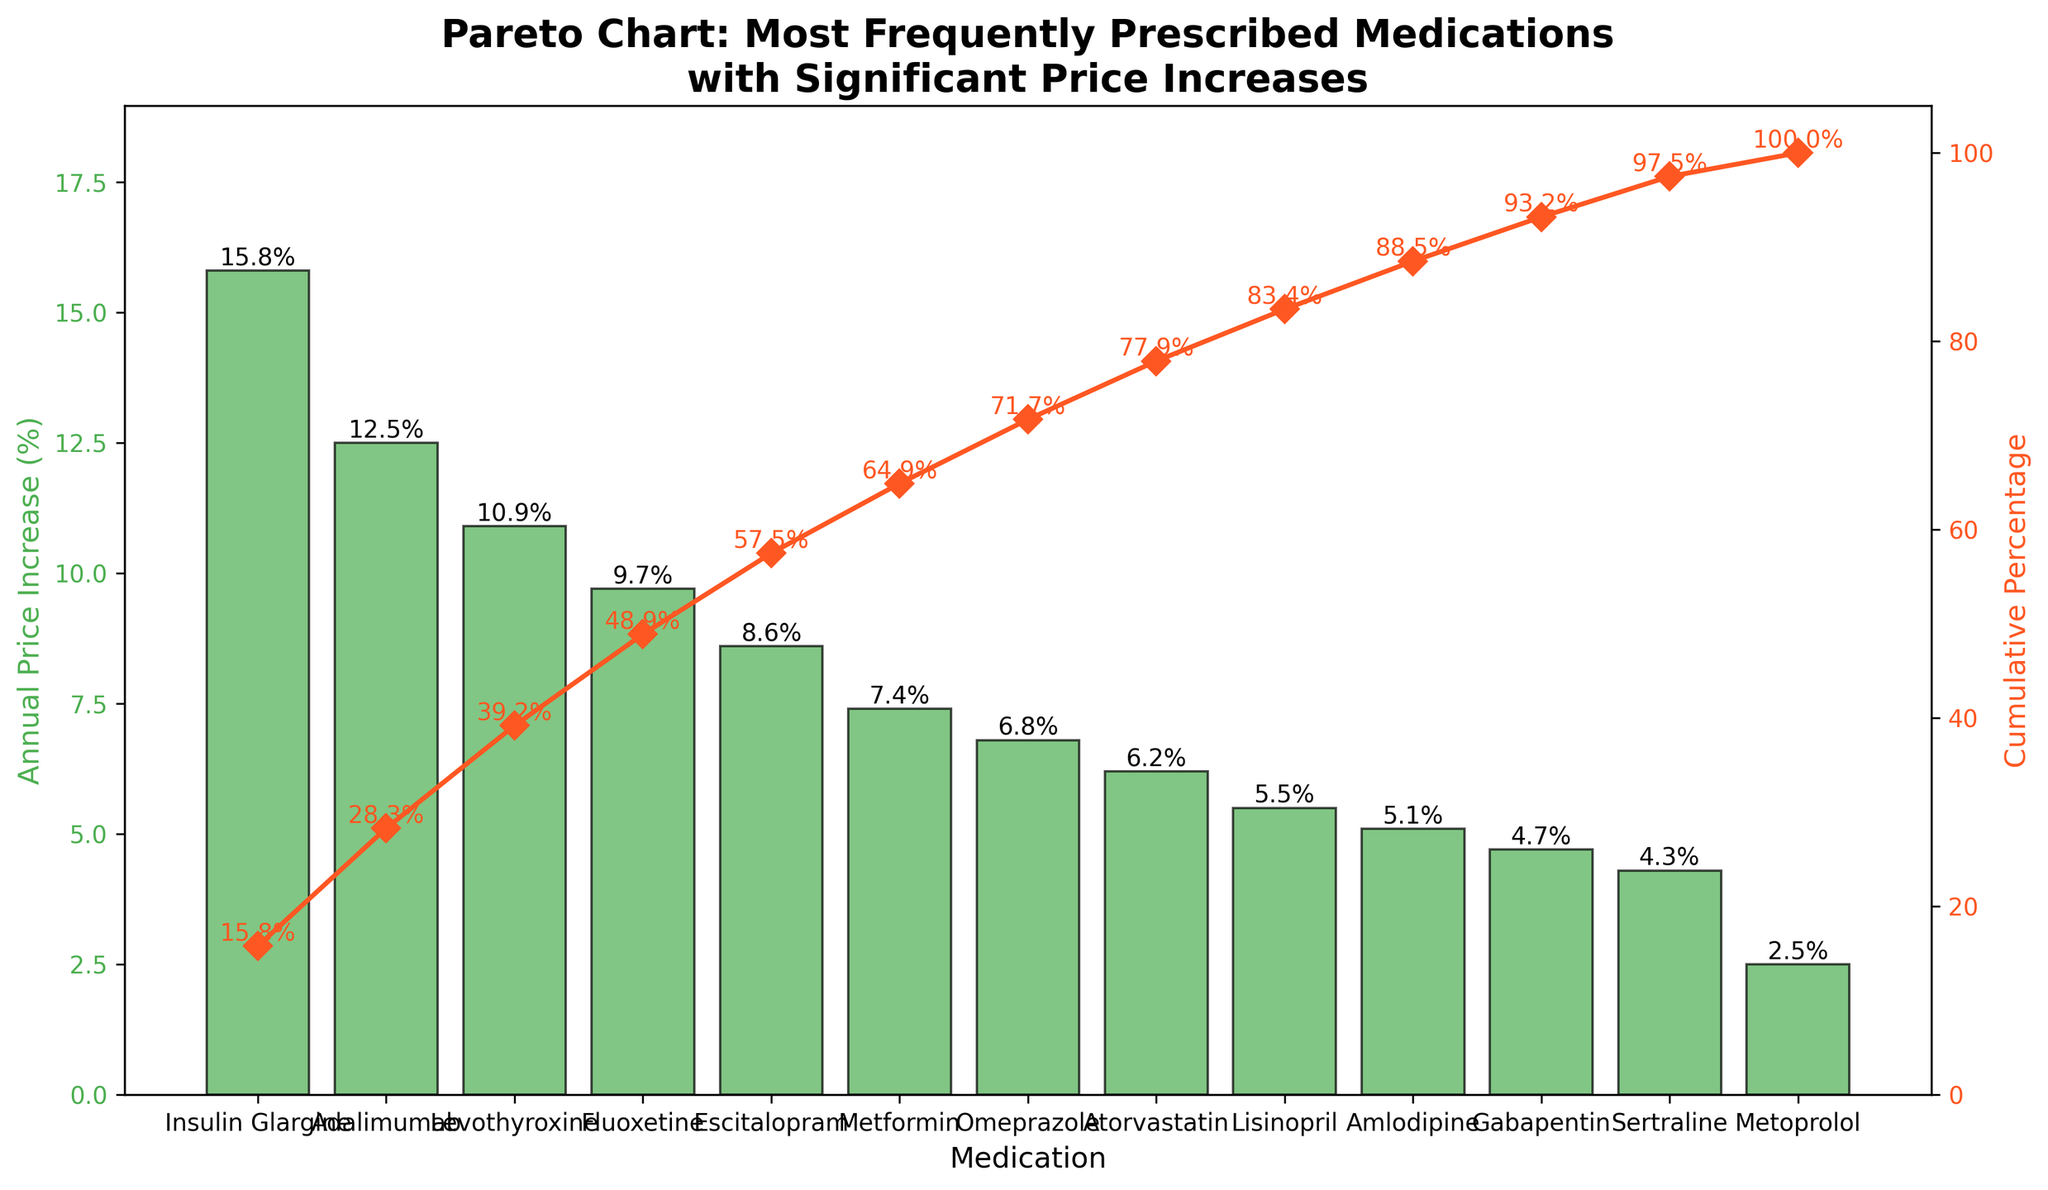What is the medication with the highest annual price increase? The bar chart shows the price increase percentages for each medication. By observing the heights of the bars, we can see that Insulin Glargine has the highest bar at 15.8%.
Answer: Insulin Glargine What is the cumulative percentage of the top 3 medications with the highest price increases? The second y-axis represents the cumulative percentage. The cumulative percentages for the top 3 medications are 15.8%, 28.3%, and 39.2%. Therefore, the cumulative percentage for the top 3 medications is the value corresponding to Levothyroxine, which is 39.2%.
Answer: 39.2% Which medication has a lower annual price increase, Metformin or Omeprazole? By comparing the heights of the bars for Metformin and Omeprazole, we can see that Metformin has an annual price increase of 7.4%, whereas Omeprazole has an increase of 6.8%. Therefore, Omeprazole has a lower annual price increase.
Answer: Omeprazole How many medications have an annual price increase greater than 10%? By examining the bars and their labels, we can count the medications with annual price increases greater than 10%. These medications are Insulin Glargine (15.8%), Adalimumab (12.5%), and Levothyroxine (10.9%). There are three such medications.
Answer: 3 What is the cumulative percentage after including Escitalopram? The cumulative percentage after including Escitalopram can be found directly from the second y-axis and is displayed next to the marker for Escitalopram. It is 57.5%.
Answer: 57.5% What is the average annual price increase of the medications listed? To find the average, add all the annual price increases and divide by the number of medications. The sum of the increases is 15.8 + 12.5 + 10.9 + 9.7 + 8.6 + 7.4 + 6.8 + 6.2 + 5.5 + 5.1 + 4.7 + 4.3 + 2.5 = 99. The number of medications is 13. Therefore, the average is 99 / 13 ≈ 7.615.
Answer: 7.615 Which medication marks the 50% cumulative percentage threshold? To identify the medication that marks the 50% cumulative percentage, look at the second y-axis. The medication whose cumulative percentage is closest to 50% but not less than it is Escitalopram at 57.5%.
Answer: Escitalopram By how much does the annual price increase of Adalimumab exceed that of Amlodipine? Compare the heights of the bars for Adalimumab and Amlodipine. Adalimumab increases by 12.5%, while Amlodipine increases by 5.1%. Subtract the smaller increase from the larger one: 12.5% - 5.1% = 7.4%.
Answer: 7.4% What medication has the lowest annual price increase, and what is its cumulative percentage? By observing the bars, the shortest bar is for Metoprolol with an annual price increase of 2.5%. Its cumulative percentage, indicated by the second y-axis, is 100%.
Answer: Metoprolol, 100% 